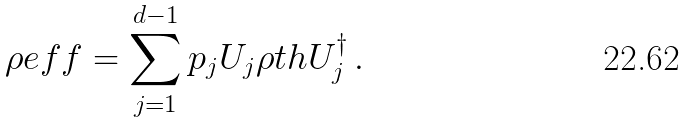Convert formula to latex. <formula><loc_0><loc_0><loc_500><loc_500>\rho e f f = \sum _ { j = 1 } ^ { d - 1 } p _ { j } U _ { j } \rho t h U _ { j } ^ { \dagger } \, .</formula> 